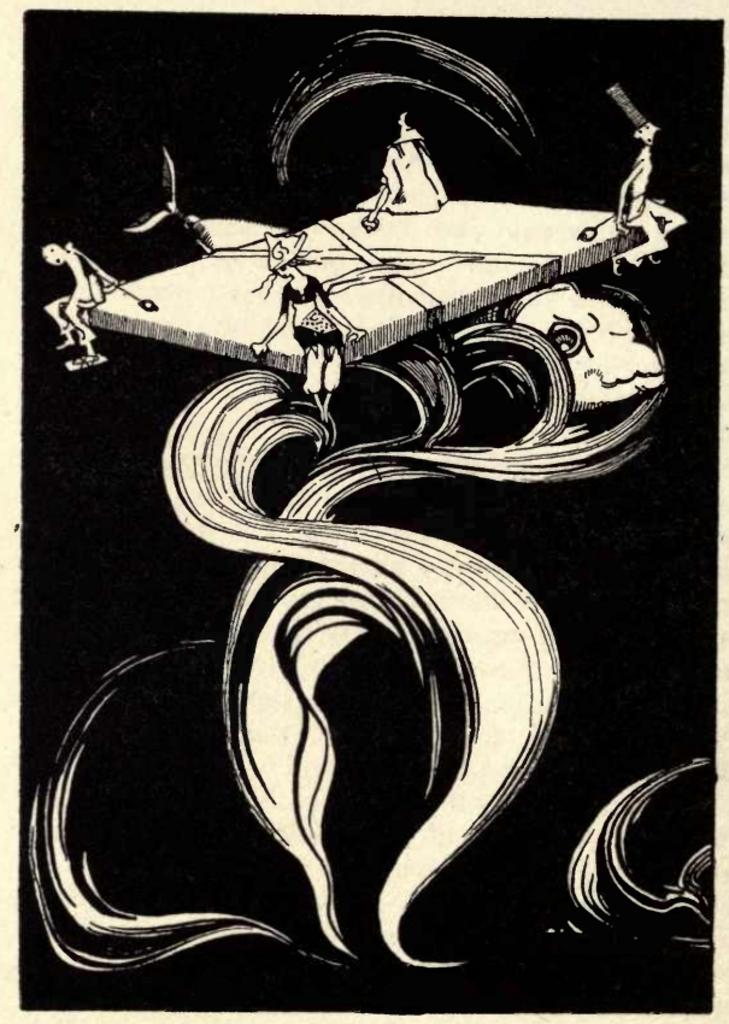What is the color of the painting in the image? The painting has a white color on a black background. How many people are sitting in the image? There are four people sitting on the corners of a surface. What is the presence of a fish in the image? There is a fish in the image. What type of toe is visible in the image? There is no toe visible in the image. What kind of teeth can be seen on the fish in the image? There is no fish with teeth present in the image; it is a regular fish. 